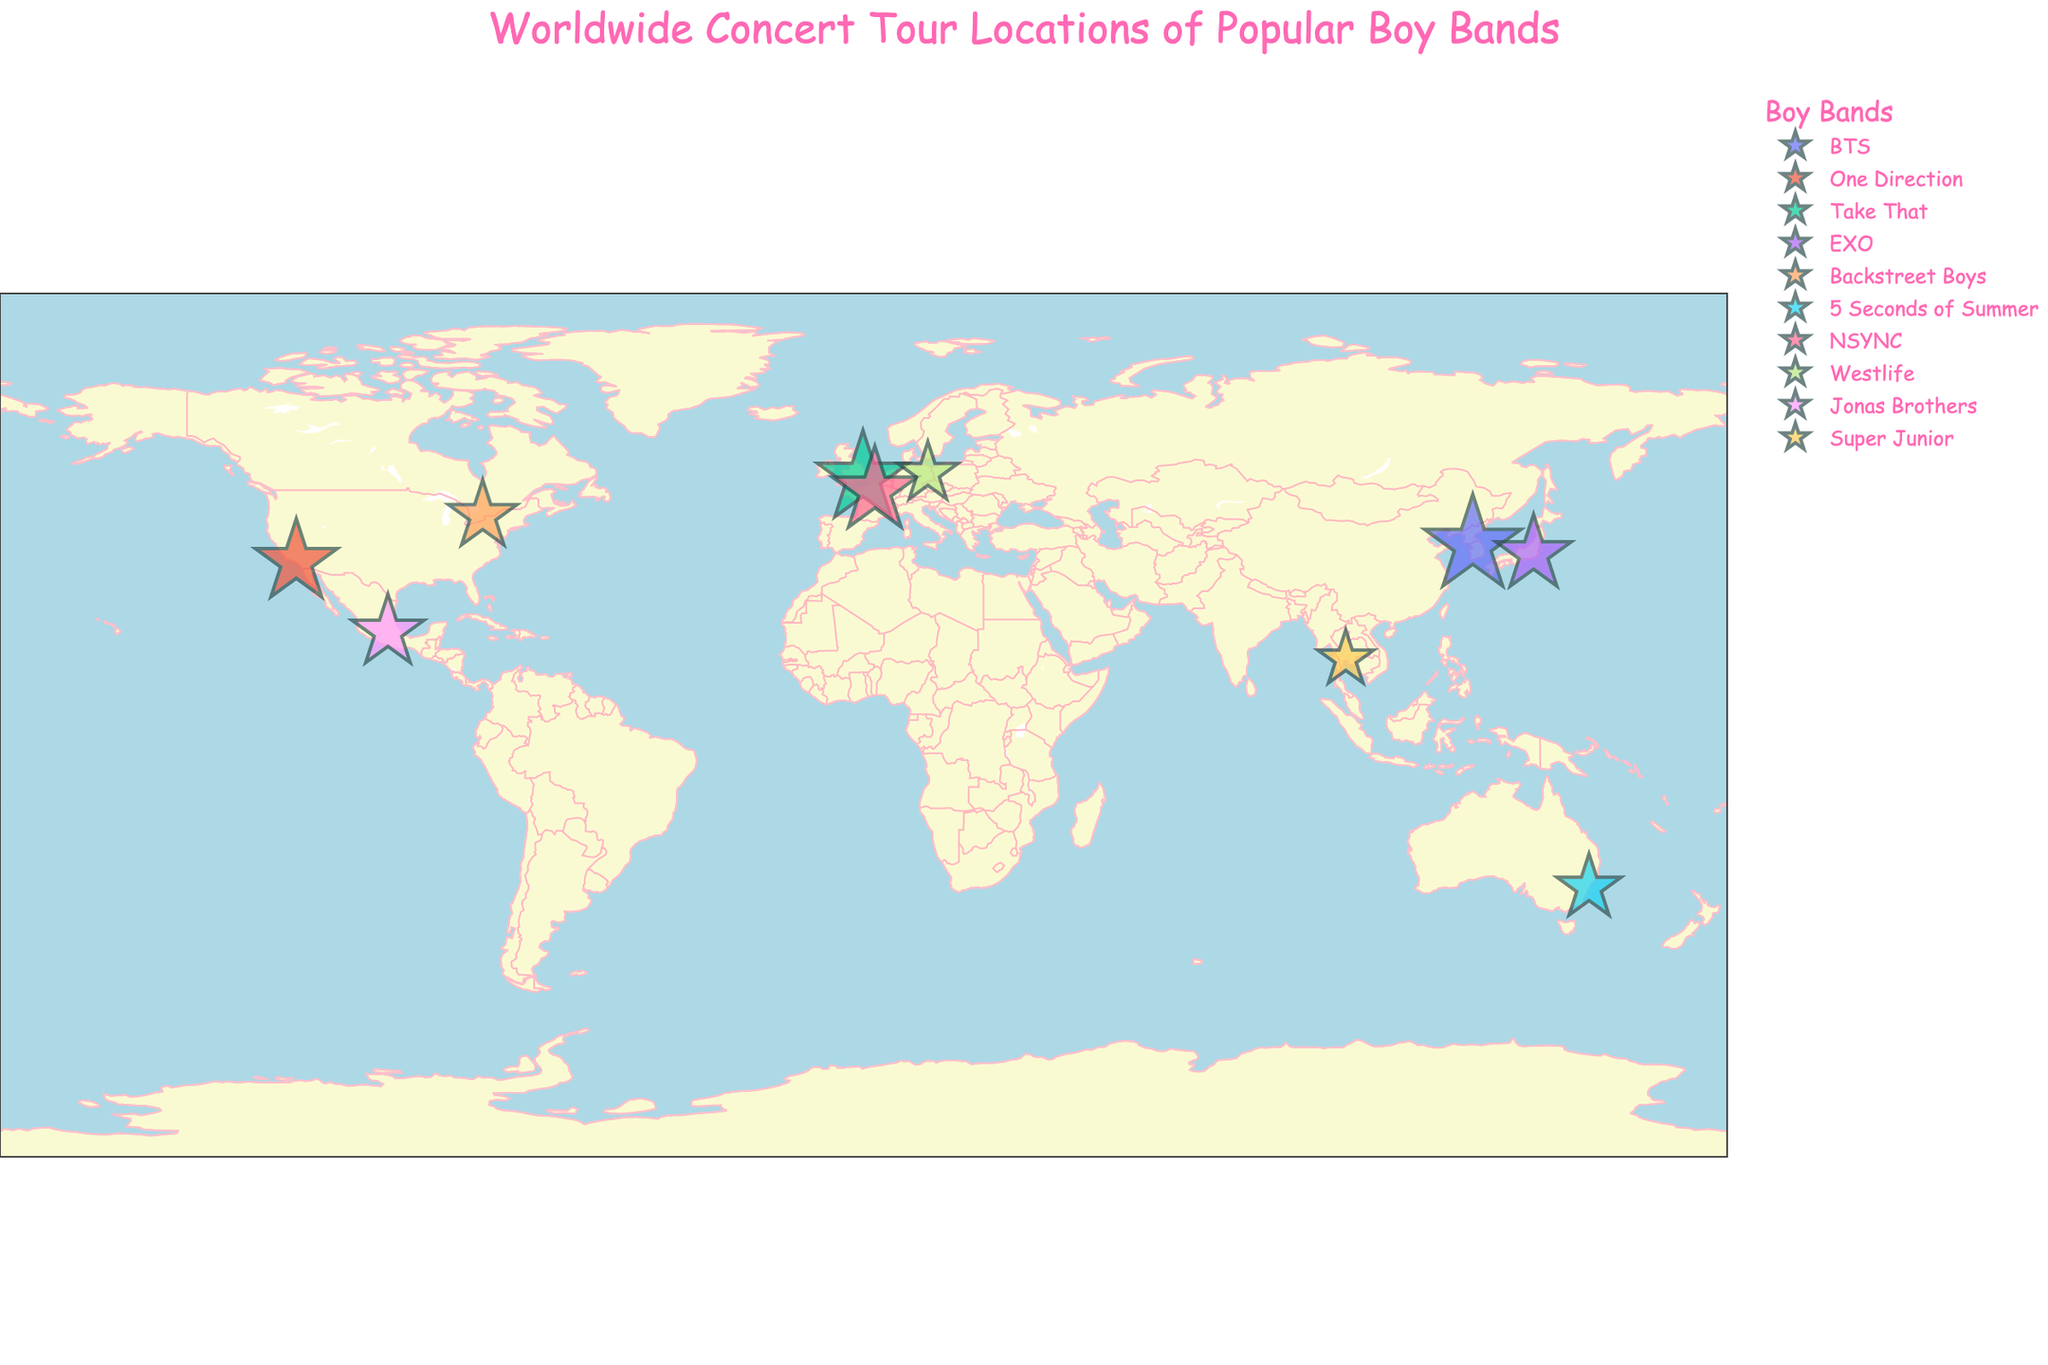How many different countries are included in the concert tour locations? By looking at the figure, count the distinct countries marked by different geographic locations.
Answer: 10 Which city hosted the concert with the highest attendance? Find the city with the largest marker size, which corresponds to the highest attendance.
Answer: Seoul What is the combined attendance for concerts in Europe? Add the attendance figures for London, Paris, and Berlin. London: 80000, Paris: 70000, Berlin: 35000. Total: 80000 + 70000 + 35000 = 185000
Answer: 185000 Which boy band had a concert in Sydney, Australia? Find the marker located in Sydney and check the band name associated with it.
Answer: 5 Seconds of Summer Which city had a smaller concert attendance than Tokyo but bigger than Bangkok? Find the attendance in Tokyo (55000) and Bangkok (30000). Look for a city with an attendance between these values. Mexico City: 50000
Answer: Mexico City On which continent did the Backstreet Boys perform their concert? Locate Toronto, Canada on the map and recognize which continent it belongs to.
Answer: North America How many cities hosted concerts with an attendance exceeding 60000? Count the cities marked with the large-sized markers where attendance is more than 60000. Los Angeles: 65000, London: 80000, Seoul: 90000, Paris: 70000.
Answer: 4 Compare the attendance figures between the concerts in Tokyo and Bangkok. Which one had a higher attendance? Look at the marker sizes representing Tokyo and Bangkok and compare the numbers. Tokyo: 55000, Bangkok: 30000.
Answer: Tokyo What is the average concert attendance for the bands that performed in Asian cities? Add up the attendance figures for Seoul, Tokyo, and Bangkok and divide by the number of cities. Seoul: 90000, Tokyo: 55000, Bangkok: 30000. (90000 + 55000 + 30000) / 3 = 57500
Answer: 57500 Which boy band performed in Paris, France, and what was their concert attendance? Check the marker placed in Paris and identify the associated band name and attendance figure.
Answer: NSYNC, 70000 